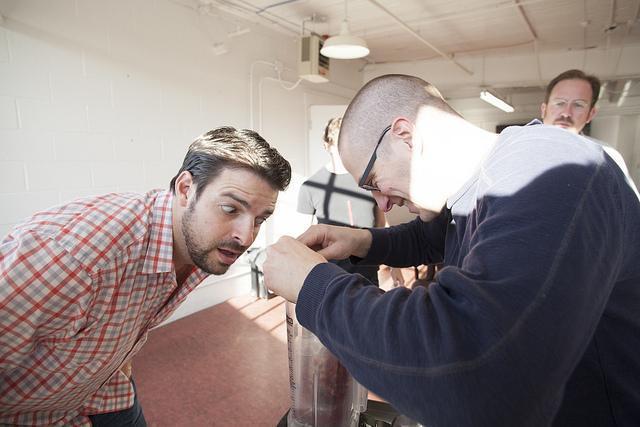How many people are there?
Give a very brief answer. 3. How many people are in the photo?
Give a very brief answer. 3. How many people in the room?
Give a very brief answer. 4. How many people can you see?
Give a very brief answer. 4. 